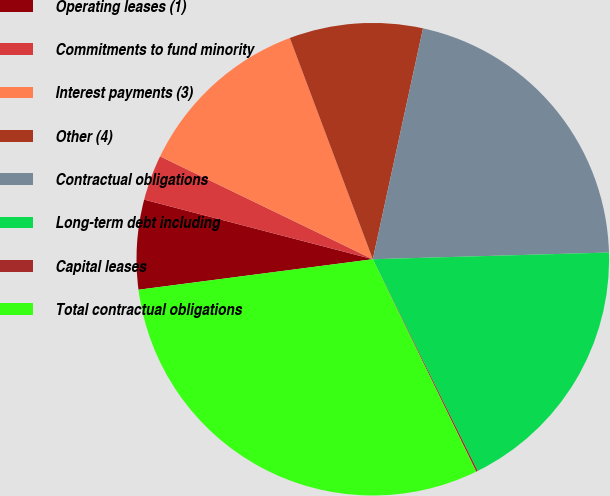Convert chart to OTSL. <chart><loc_0><loc_0><loc_500><loc_500><pie_chart><fcel>Operating leases (1)<fcel>Commitments to fund minority<fcel>Interest payments (3)<fcel>Other (4)<fcel>Contractual obligations<fcel>Long-term debt including<fcel>Capital leases<fcel>Total contractual obligations<nl><fcel>6.12%<fcel>3.11%<fcel>12.12%<fcel>9.12%<fcel>21.14%<fcel>18.13%<fcel>0.11%<fcel>30.15%<nl></chart> 